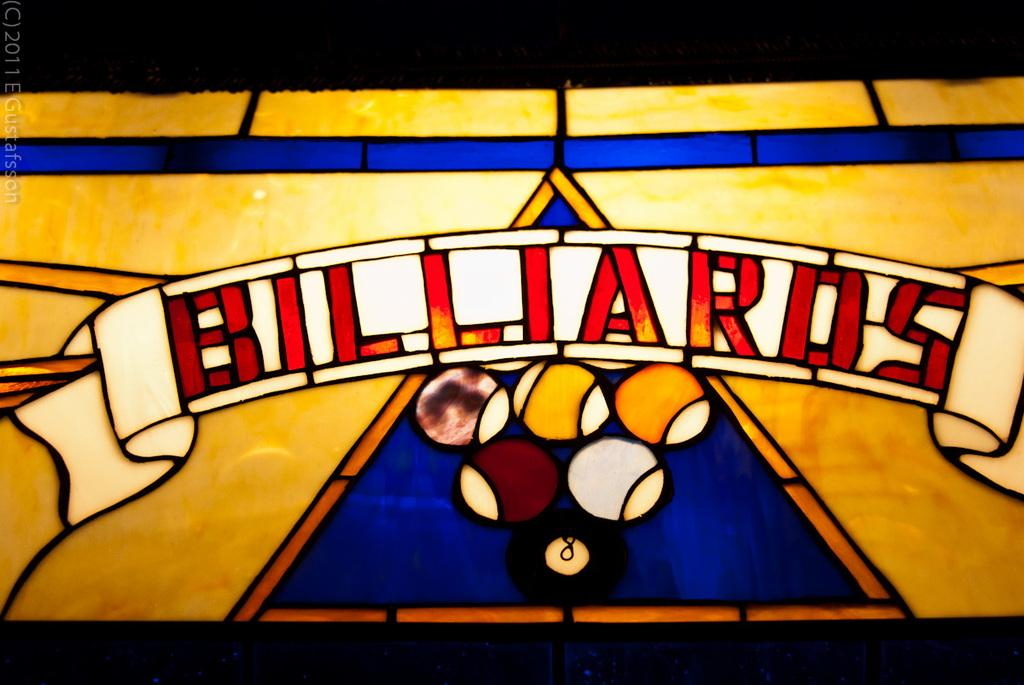What type of glass is present in the image? There is stained glass in the image. What else can be seen in the image besides the stained glass? Balls are visible in the image. Is there any text or writing in the image? Yes, there is writing on the stained glass or balls. How would you describe the overall appearance of the image? The image is colorful. What type of shop can be seen at the end of the image? There is no shop present in the image, and the concept of "end" is not applicable to this image. What type of sport is being played with the balls in the image? The image does not depict any specific sport being played; it only shows balls and stained glass. 